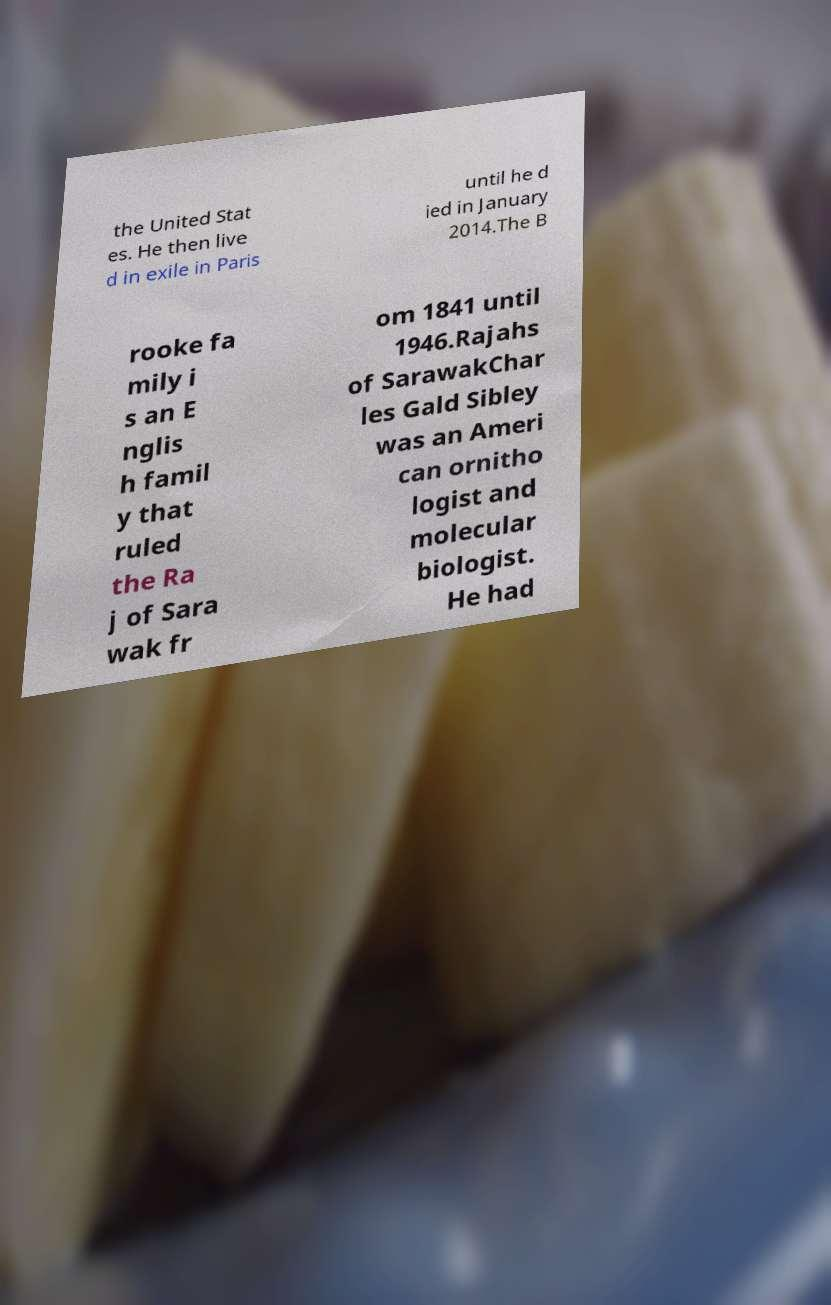Please read and relay the text visible in this image. What does it say? the United Stat es. He then live d in exile in Paris until he d ied in January 2014.The B rooke fa mily i s an E nglis h famil y that ruled the Ra j of Sara wak fr om 1841 until 1946.Rajahs of SarawakChar les Gald Sibley was an Ameri can ornitho logist and molecular biologist. He had 